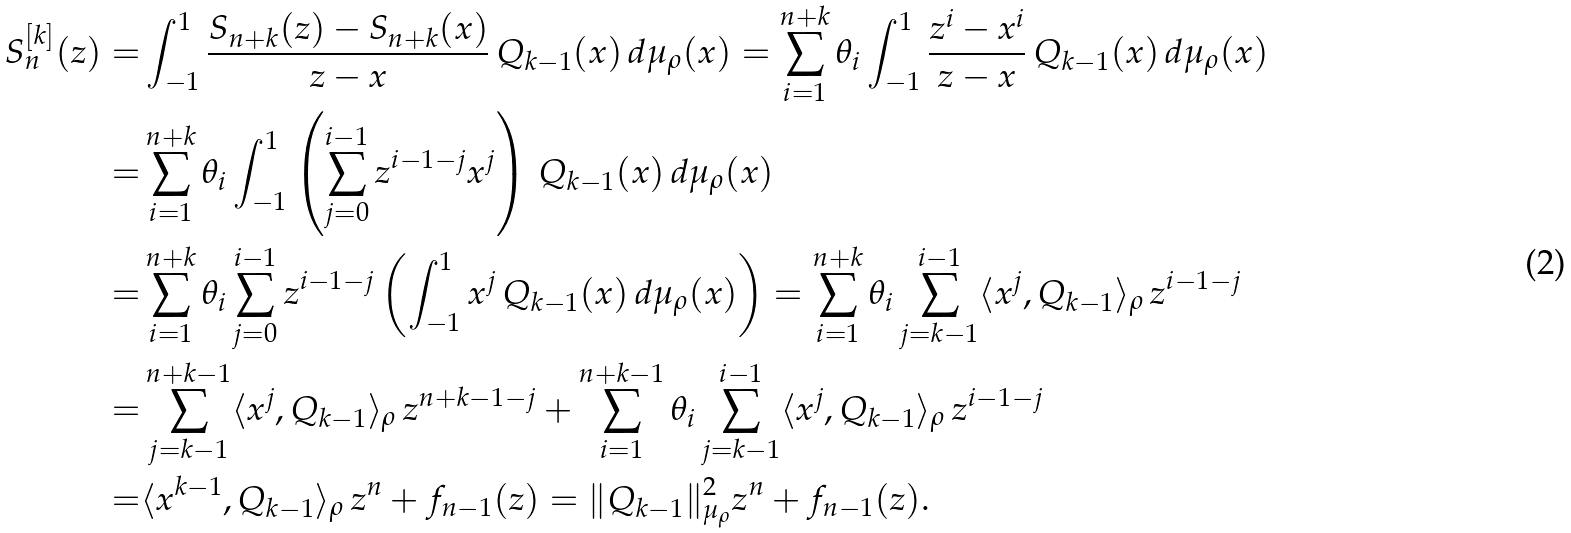<formula> <loc_0><loc_0><loc_500><loc_500>S ^ { [ k ] } _ { n } ( z ) = & \int _ { - 1 } ^ { 1 } \frac { S _ { n + k } ( z ) - S _ { n + k } ( x ) } { z - x } \, Q _ { k - 1 } ( x ) \, d \mu _ { \rho } ( x ) = \sum _ { i = 1 } ^ { n + k } \theta _ { i } \int _ { - 1 } ^ { 1 } \frac { z ^ { i } - x ^ { i } } { z - x } \, Q _ { k - 1 } ( x ) \, d \mu _ { \rho } ( x ) \\ = & \sum _ { i = 1 } ^ { n + k } \theta _ { i } \int _ { - 1 } ^ { 1 } \left ( \sum _ { j = 0 } ^ { i - 1 } z ^ { i - 1 - j } x ^ { j } \right ) \, Q _ { k - 1 } ( x ) \, d \mu _ { \rho } ( x ) \\ = & \sum _ { i = 1 } ^ { n + k } \theta _ { i } \sum _ { j = 0 } ^ { i - 1 } z ^ { i - 1 - j } \left ( \int _ { - 1 } ^ { 1 } x ^ { j } \, Q _ { k - 1 } ( x ) \, d \mu _ { \rho } ( x ) \right ) = \sum _ { i = 1 } ^ { n + k } \theta _ { i } \sum _ { j = k - 1 } ^ { i - 1 } \langle x ^ { j } , Q _ { k - 1 } \rangle _ { \rho } \, z ^ { i - 1 - j } \\ = & \sum _ { j = k - 1 } ^ { n + k - 1 } \langle x ^ { j } , Q _ { k - 1 } \rangle _ { \rho } \, z ^ { n + k - 1 - j } + \sum _ { i = 1 } ^ { n + k - 1 } \theta _ { i } \sum _ { j = k - 1 } ^ { i - 1 } \langle x ^ { j } , Q _ { k - 1 } \rangle _ { \rho } \, z ^ { i - 1 - j } \\ = & \langle x ^ { k - 1 } , Q _ { k - 1 } \rangle _ { \rho } \, z ^ { n } + f _ { n - 1 } ( z ) = \| Q _ { k - 1 } \| _ { \mu _ { \rho } } ^ { 2 } z ^ { n } + f _ { n - 1 } ( z ) .</formula> 